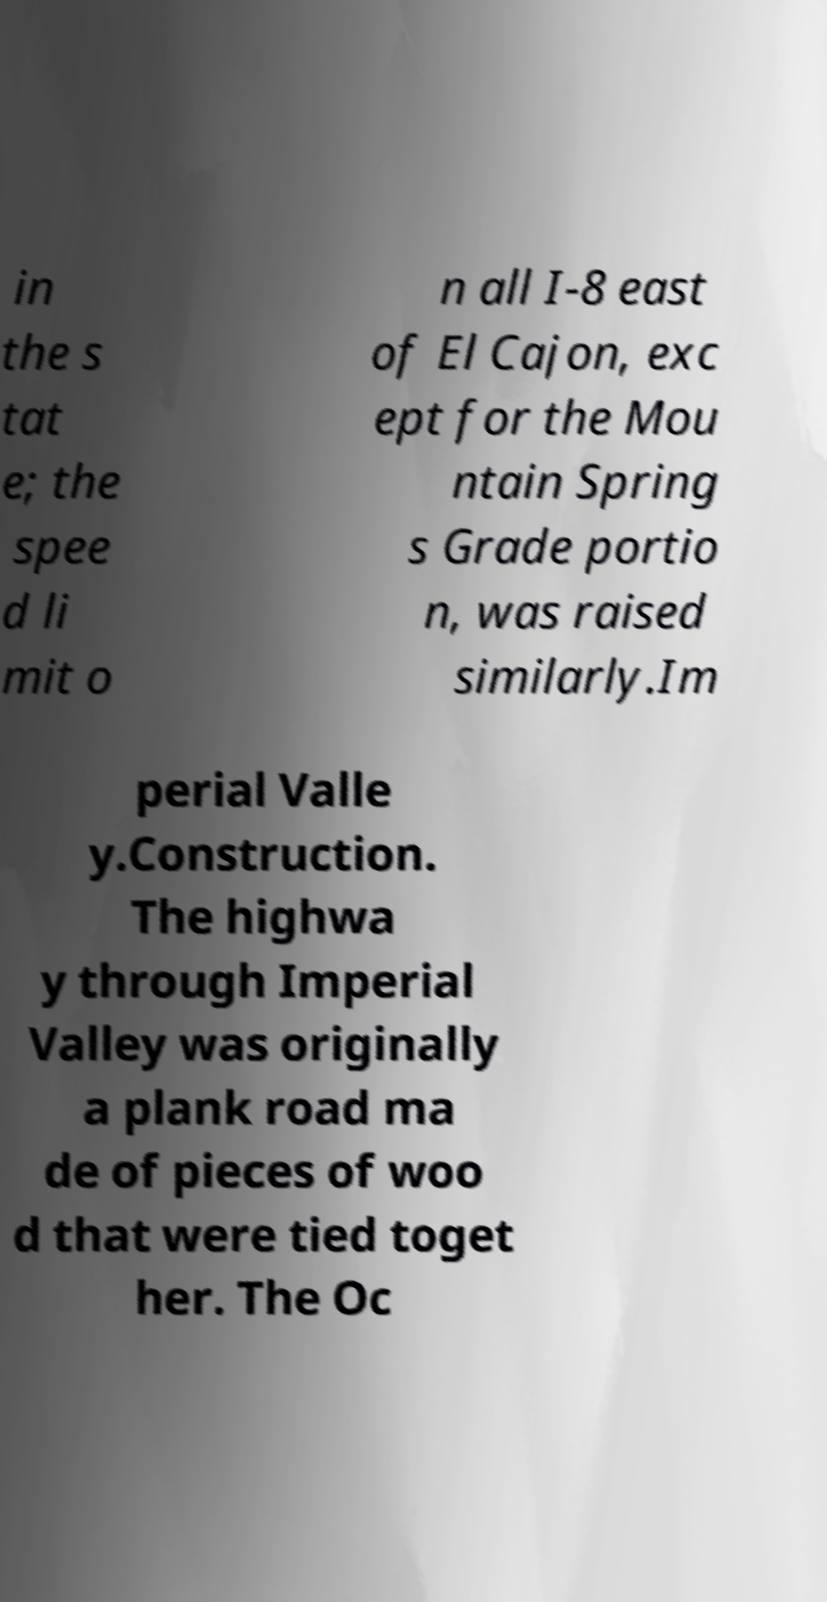Please read and relay the text visible in this image. What does it say? in the s tat e; the spee d li mit o n all I-8 east of El Cajon, exc ept for the Mou ntain Spring s Grade portio n, was raised similarly.Im perial Valle y.Construction. The highwa y through Imperial Valley was originally a plank road ma de of pieces of woo d that were tied toget her. The Oc 